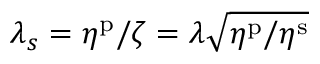<formula> <loc_0><loc_0><loc_500><loc_500>\lambda _ { s } = \eta ^ { p } / \zeta = \lambda \sqrt { \eta ^ { p } / \eta ^ { s } }</formula> 